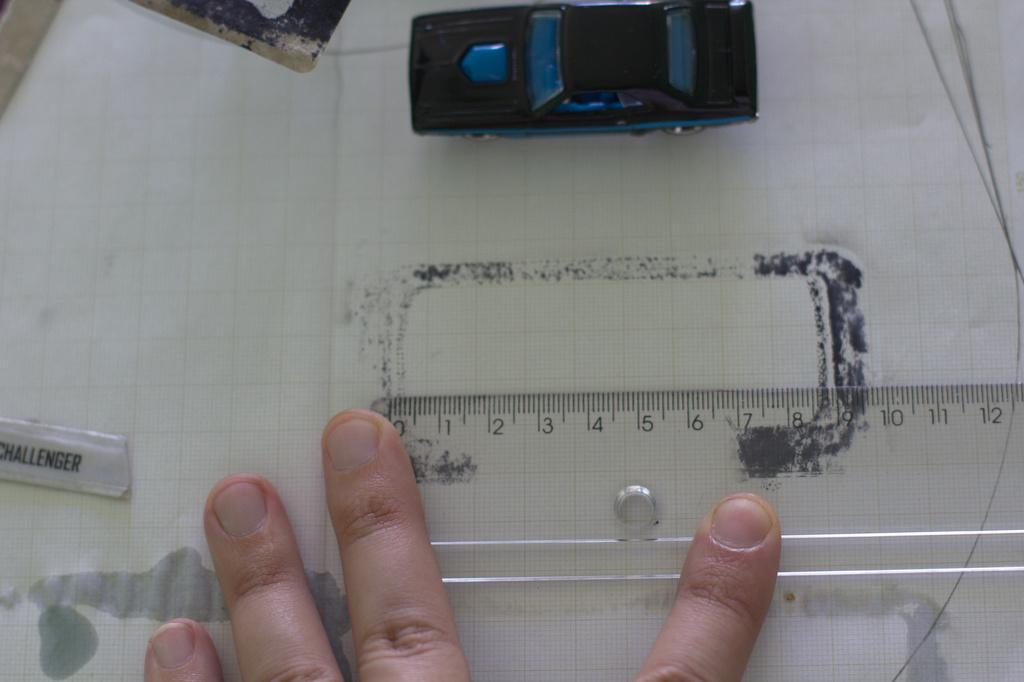What is the person's fingers touching in the image? The person's fingers are on a scale in the image. What other item can be seen in the image besides the scale? There is a toy in the image. What is the purpose of the paper in the image? There are other objects on a paper in the image, which suggests that the paper might be used for organizing or displaying items. How many spiders are crawling on the toy in the image? There are no spiders present in the image; it only features a toy and a person's fingers on a scale. 